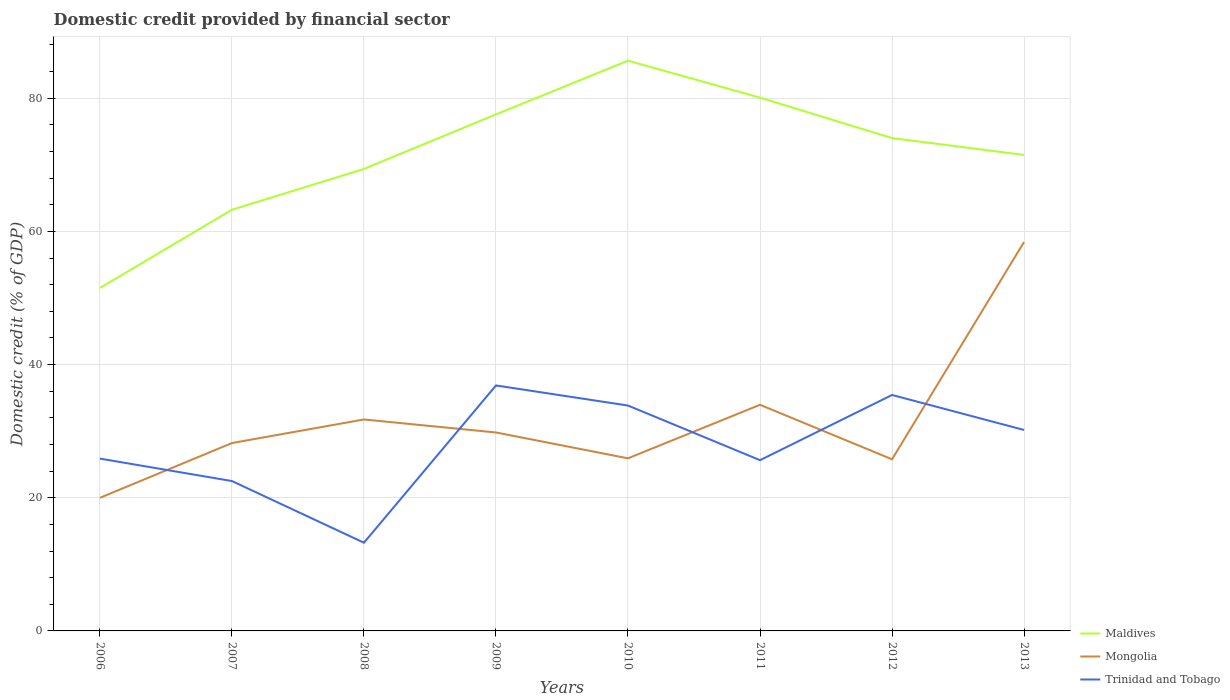Does the line corresponding to Mongolia intersect with the line corresponding to Maldives?
Your answer should be very brief. No. Is the number of lines equal to the number of legend labels?
Give a very brief answer. Yes. Across all years, what is the maximum domestic credit in Mongolia?
Keep it short and to the point. 19.99. What is the total domestic credit in Trinidad and Tobago in the graph?
Your response must be concise. -9.56. What is the difference between the highest and the second highest domestic credit in Maldives?
Your response must be concise. 34.13. Is the domestic credit in Maldives strictly greater than the domestic credit in Mongolia over the years?
Give a very brief answer. No. How many lines are there?
Give a very brief answer. 3. How many years are there in the graph?
Keep it short and to the point. 8. What is the difference between two consecutive major ticks on the Y-axis?
Offer a very short reply. 20. Are the values on the major ticks of Y-axis written in scientific E-notation?
Provide a short and direct response. No. Does the graph contain grids?
Ensure brevity in your answer.  Yes. How many legend labels are there?
Offer a very short reply. 3. How are the legend labels stacked?
Offer a terse response. Vertical. What is the title of the graph?
Your answer should be compact. Domestic credit provided by financial sector. What is the label or title of the Y-axis?
Your answer should be very brief. Domestic credit (% of GDP). What is the Domestic credit (% of GDP) of Maldives in 2006?
Provide a succinct answer. 51.5. What is the Domestic credit (% of GDP) in Mongolia in 2006?
Your response must be concise. 19.99. What is the Domestic credit (% of GDP) in Trinidad and Tobago in 2006?
Offer a very short reply. 25.88. What is the Domestic credit (% of GDP) in Maldives in 2007?
Provide a succinct answer. 63.25. What is the Domestic credit (% of GDP) in Mongolia in 2007?
Your answer should be compact. 28.21. What is the Domestic credit (% of GDP) in Trinidad and Tobago in 2007?
Offer a terse response. 22.51. What is the Domestic credit (% of GDP) of Maldives in 2008?
Your response must be concise. 69.38. What is the Domestic credit (% of GDP) of Mongolia in 2008?
Ensure brevity in your answer.  31.76. What is the Domestic credit (% of GDP) of Trinidad and Tobago in 2008?
Your answer should be compact. 13.25. What is the Domestic credit (% of GDP) in Maldives in 2009?
Provide a short and direct response. 77.58. What is the Domestic credit (% of GDP) of Mongolia in 2009?
Your answer should be very brief. 29.8. What is the Domestic credit (% of GDP) in Trinidad and Tobago in 2009?
Your response must be concise. 36.87. What is the Domestic credit (% of GDP) in Maldives in 2010?
Offer a terse response. 85.64. What is the Domestic credit (% of GDP) in Mongolia in 2010?
Your answer should be compact. 25.92. What is the Domestic credit (% of GDP) in Trinidad and Tobago in 2010?
Keep it short and to the point. 33.85. What is the Domestic credit (% of GDP) in Maldives in 2011?
Ensure brevity in your answer.  80.09. What is the Domestic credit (% of GDP) of Mongolia in 2011?
Make the answer very short. 33.96. What is the Domestic credit (% of GDP) of Trinidad and Tobago in 2011?
Offer a very short reply. 25.64. What is the Domestic credit (% of GDP) of Maldives in 2012?
Your answer should be compact. 74.02. What is the Domestic credit (% of GDP) in Mongolia in 2012?
Ensure brevity in your answer.  25.77. What is the Domestic credit (% of GDP) of Trinidad and Tobago in 2012?
Provide a succinct answer. 35.44. What is the Domestic credit (% of GDP) in Maldives in 2013?
Ensure brevity in your answer.  71.48. What is the Domestic credit (% of GDP) in Mongolia in 2013?
Provide a succinct answer. 58.41. What is the Domestic credit (% of GDP) of Trinidad and Tobago in 2013?
Offer a very short reply. 30.18. Across all years, what is the maximum Domestic credit (% of GDP) of Maldives?
Your answer should be very brief. 85.64. Across all years, what is the maximum Domestic credit (% of GDP) in Mongolia?
Provide a succinct answer. 58.41. Across all years, what is the maximum Domestic credit (% of GDP) in Trinidad and Tobago?
Keep it short and to the point. 36.87. Across all years, what is the minimum Domestic credit (% of GDP) of Maldives?
Your response must be concise. 51.5. Across all years, what is the minimum Domestic credit (% of GDP) of Mongolia?
Ensure brevity in your answer.  19.99. Across all years, what is the minimum Domestic credit (% of GDP) in Trinidad and Tobago?
Make the answer very short. 13.25. What is the total Domestic credit (% of GDP) in Maldives in the graph?
Ensure brevity in your answer.  572.94. What is the total Domestic credit (% of GDP) of Mongolia in the graph?
Offer a terse response. 253.83. What is the total Domestic credit (% of GDP) in Trinidad and Tobago in the graph?
Provide a succinct answer. 223.6. What is the difference between the Domestic credit (% of GDP) of Maldives in 2006 and that in 2007?
Ensure brevity in your answer.  -11.75. What is the difference between the Domestic credit (% of GDP) in Mongolia in 2006 and that in 2007?
Make the answer very short. -8.23. What is the difference between the Domestic credit (% of GDP) in Trinidad and Tobago in 2006 and that in 2007?
Your response must be concise. 3.37. What is the difference between the Domestic credit (% of GDP) in Maldives in 2006 and that in 2008?
Your response must be concise. -17.88. What is the difference between the Domestic credit (% of GDP) of Mongolia in 2006 and that in 2008?
Your response must be concise. -11.77. What is the difference between the Domestic credit (% of GDP) in Trinidad and Tobago in 2006 and that in 2008?
Give a very brief answer. 12.63. What is the difference between the Domestic credit (% of GDP) in Maldives in 2006 and that in 2009?
Provide a short and direct response. -26.07. What is the difference between the Domestic credit (% of GDP) of Mongolia in 2006 and that in 2009?
Your response must be concise. -9.82. What is the difference between the Domestic credit (% of GDP) of Trinidad and Tobago in 2006 and that in 2009?
Keep it short and to the point. -10.98. What is the difference between the Domestic credit (% of GDP) of Maldives in 2006 and that in 2010?
Provide a short and direct response. -34.13. What is the difference between the Domestic credit (% of GDP) of Mongolia in 2006 and that in 2010?
Give a very brief answer. -5.93. What is the difference between the Domestic credit (% of GDP) in Trinidad and Tobago in 2006 and that in 2010?
Give a very brief answer. -7.97. What is the difference between the Domestic credit (% of GDP) of Maldives in 2006 and that in 2011?
Make the answer very short. -28.58. What is the difference between the Domestic credit (% of GDP) in Mongolia in 2006 and that in 2011?
Offer a very short reply. -13.97. What is the difference between the Domestic credit (% of GDP) in Trinidad and Tobago in 2006 and that in 2011?
Offer a terse response. 0.24. What is the difference between the Domestic credit (% of GDP) of Maldives in 2006 and that in 2012?
Offer a terse response. -22.51. What is the difference between the Domestic credit (% of GDP) in Mongolia in 2006 and that in 2012?
Your response must be concise. -5.79. What is the difference between the Domestic credit (% of GDP) of Trinidad and Tobago in 2006 and that in 2012?
Offer a very short reply. -9.56. What is the difference between the Domestic credit (% of GDP) in Maldives in 2006 and that in 2013?
Your answer should be very brief. -19.98. What is the difference between the Domestic credit (% of GDP) of Mongolia in 2006 and that in 2013?
Ensure brevity in your answer.  -38.42. What is the difference between the Domestic credit (% of GDP) of Trinidad and Tobago in 2006 and that in 2013?
Offer a terse response. -4.3. What is the difference between the Domestic credit (% of GDP) in Maldives in 2007 and that in 2008?
Keep it short and to the point. -6.13. What is the difference between the Domestic credit (% of GDP) of Mongolia in 2007 and that in 2008?
Give a very brief answer. -3.54. What is the difference between the Domestic credit (% of GDP) in Trinidad and Tobago in 2007 and that in 2008?
Make the answer very short. 9.26. What is the difference between the Domestic credit (% of GDP) in Maldives in 2007 and that in 2009?
Ensure brevity in your answer.  -14.33. What is the difference between the Domestic credit (% of GDP) of Mongolia in 2007 and that in 2009?
Your answer should be very brief. -1.59. What is the difference between the Domestic credit (% of GDP) in Trinidad and Tobago in 2007 and that in 2009?
Provide a succinct answer. -14.36. What is the difference between the Domestic credit (% of GDP) of Maldives in 2007 and that in 2010?
Offer a terse response. -22.39. What is the difference between the Domestic credit (% of GDP) in Mongolia in 2007 and that in 2010?
Provide a short and direct response. 2.29. What is the difference between the Domestic credit (% of GDP) in Trinidad and Tobago in 2007 and that in 2010?
Ensure brevity in your answer.  -11.34. What is the difference between the Domestic credit (% of GDP) in Maldives in 2007 and that in 2011?
Your answer should be very brief. -16.84. What is the difference between the Domestic credit (% of GDP) in Mongolia in 2007 and that in 2011?
Offer a very short reply. -5.75. What is the difference between the Domestic credit (% of GDP) of Trinidad and Tobago in 2007 and that in 2011?
Your answer should be compact. -3.13. What is the difference between the Domestic credit (% of GDP) of Maldives in 2007 and that in 2012?
Your response must be concise. -10.77. What is the difference between the Domestic credit (% of GDP) in Mongolia in 2007 and that in 2012?
Make the answer very short. 2.44. What is the difference between the Domestic credit (% of GDP) in Trinidad and Tobago in 2007 and that in 2012?
Your answer should be compact. -12.93. What is the difference between the Domestic credit (% of GDP) in Maldives in 2007 and that in 2013?
Provide a short and direct response. -8.23. What is the difference between the Domestic credit (% of GDP) in Mongolia in 2007 and that in 2013?
Make the answer very short. -30.2. What is the difference between the Domestic credit (% of GDP) in Trinidad and Tobago in 2007 and that in 2013?
Make the answer very short. -7.67. What is the difference between the Domestic credit (% of GDP) of Maldives in 2008 and that in 2009?
Your answer should be very brief. -8.19. What is the difference between the Domestic credit (% of GDP) of Mongolia in 2008 and that in 2009?
Provide a short and direct response. 1.95. What is the difference between the Domestic credit (% of GDP) of Trinidad and Tobago in 2008 and that in 2009?
Offer a terse response. -23.62. What is the difference between the Domestic credit (% of GDP) of Maldives in 2008 and that in 2010?
Your answer should be very brief. -16.26. What is the difference between the Domestic credit (% of GDP) of Mongolia in 2008 and that in 2010?
Give a very brief answer. 5.83. What is the difference between the Domestic credit (% of GDP) in Trinidad and Tobago in 2008 and that in 2010?
Your answer should be compact. -20.6. What is the difference between the Domestic credit (% of GDP) in Maldives in 2008 and that in 2011?
Ensure brevity in your answer.  -10.71. What is the difference between the Domestic credit (% of GDP) in Mongolia in 2008 and that in 2011?
Offer a terse response. -2.2. What is the difference between the Domestic credit (% of GDP) in Trinidad and Tobago in 2008 and that in 2011?
Your response must be concise. -12.4. What is the difference between the Domestic credit (% of GDP) in Maldives in 2008 and that in 2012?
Offer a terse response. -4.63. What is the difference between the Domestic credit (% of GDP) in Mongolia in 2008 and that in 2012?
Keep it short and to the point. 5.98. What is the difference between the Domestic credit (% of GDP) in Trinidad and Tobago in 2008 and that in 2012?
Your answer should be very brief. -22.19. What is the difference between the Domestic credit (% of GDP) in Maldives in 2008 and that in 2013?
Keep it short and to the point. -2.1. What is the difference between the Domestic credit (% of GDP) of Mongolia in 2008 and that in 2013?
Ensure brevity in your answer.  -26.66. What is the difference between the Domestic credit (% of GDP) in Trinidad and Tobago in 2008 and that in 2013?
Provide a succinct answer. -16.93. What is the difference between the Domestic credit (% of GDP) of Maldives in 2009 and that in 2010?
Offer a very short reply. -8.06. What is the difference between the Domestic credit (% of GDP) in Mongolia in 2009 and that in 2010?
Offer a very short reply. 3.88. What is the difference between the Domestic credit (% of GDP) of Trinidad and Tobago in 2009 and that in 2010?
Your answer should be compact. 3.02. What is the difference between the Domestic credit (% of GDP) in Maldives in 2009 and that in 2011?
Provide a short and direct response. -2.51. What is the difference between the Domestic credit (% of GDP) in Mongolia in 2009 and that in 2011?
Offer a terse response. -4.16. What is the difference between the Domestic credit (% of GDP) in Trinidad and Tobago in 2009 and that in 2011?
Your response must be concise. 11.22. What is the difference between the Domestic credit (% of GDP) in Maldives in 2009 and that in 2012?
Give a very brief answer. 3.56. What is the difference between the Domestic credit (% of GDP) of Mongolia in 2009 and that in 2012?
Keep it short and to the point. 4.03. What is the difference between the Domestic credit (% of GDP) of Trinidad and Tobago in 2009 and that in 2012?
Your response must be concise. 1.43. What is the difference between the Domestic credit (% of GDP) of Maldives in 2009 and that in 2013?
Make the answer very short. 6.09. What is the difference between the Domestic credit (% of GDP) of Mongolia in 2009 and that in 2013?
Offer a terse response. -28.61. What is the difference between the Domestic credit (% of GDP) in Trinidad and Tobago in 2009 and that in 2013?
Your response must be concise. 6.69. What is the difference between the Domestic credit (% of GDP) in Maldives in 2010 and that in 2011?
Give a very brief answer. 5.55. What is the difference between the Domestic credit (% of GDP) of Mongolia in 2010 and that in 2011?
Give a very brief answer. -8.04. What is the difference between the Domestic credit (% of GDP) in Trinidad and Tobago in 2010 and that in 2011?
Give a very brief answer. 8.21. What is the difference between the Domestic credit (% of GDP) of Maldives in 2010 and that in 2012?
Keep it short and to the point. 11.62. What is the difference between the Domestic credit (% of GDP) in Mongolia in 2010 and that in 2012?
Your answer should be compact. 0.15. What is the difference between the Domestic credit (% of GDP) of Trinidad and Tobago in 2010 and that in 2012?
Ensure brevity in your answer.  -1.59. What is the difference between the Domestic credit (% of GDP) in Maldives in 2010 and that in 2013?
Give a very brief answer. 14.16. What is the difference between the Domestic credit (% of GDP) in Mongolia in 2010 and that in 2013?
Give a very brief answer. -32.49. What is the difference between the Domestic credit (% of GDP) in Trinidad and Tobago in 2010 and that in 2013?
Your answer should be very brief. 3.67. What is the difference between the Domestic credit (% of GDP) in Maldives in 2011 and that in 2012?
Make the answer very short. 6.07. What is the difference between the Domestic credit (% of GDP) of Mongolia in 2011 and that in 2012?
Ensure brevity in your answer.  8.19. What is the difference between the Domestic credit (% of GDP) of Trinidad and Tobago in 2011 and that in 2012?
Make the answer very short. -9.8. What is the difference between the Domestic credit (% of GDP) of Maldives in 2011 and that in 2013?
Make the answer very short. 8.61. What is the difference between the Domestic credit (% of GDP) of Mongolia in 2011 and that in 2013?
Give a very brief answer. -24.45. What is the difference between the Domestic credit (% of GDP) of Trinidad and Tobago in 2011 and that in 2013?
Your answer should be compact. -4.54. What is the difference between the Domestic credit (% of GDP) of Maldives in 2012 and that in 2013?
Your answer should be compact. 2.53. What is the difference between the Domestic credit (% of GDP) of Mongolia in 2012 and that in 2013?
Make the answer very short. -32.64. What is the difference between the Domestic credit (% of GDP) of Trinidad and Tobago in 2012 and that in 2013?
Your answer should be compact. 5.26. What is the difference between the Domestic credit (% of GDP) of Maldives in 2006 and the Domestic credit (% of GDP) of Mongolia in 2007?
Provide a short and direct response. 23.29. What is the difference between the Domestic credit (% of GDP) in Maldives in 2006 and the Domestic credit (% of GDP) in Trinidad and Tobago in 2007?
Your answer should be compact. 29. What is the difference between the Domestic credit (% of GDP) of Mongolia in 2006 and the Domestic credit (% of GDP) of Trinidad and Tobago in 2007?
Give a very brief answer. -2.52. What is the difference between the Domestic credit (% of GDP) in Maldives in 2006 and the Domestic credit (% of GDP) in Mongolia in 2008?
Provide a succinct answer. 19.75. What is the difference between the Domestic credit (% of GDP) in Maldives in 2006 and the Domestic credit (% of GDP) in Trinidad and Tobago in 2008?
Your response must be concise. 38.26. What is the difference between the Domestic credit (% of GDP) of Mongolia in 2006 and the Domestic credit (% of GDP) of Trinidad and Tobago in 2008?
Make the answer very short. 6.74. What is the difference between the Domestic credit (% of GDP) of Maldives in 2006 and the Domestic credit (% of GDP) of Mongolia in 2009?
Your response must be concise. 21.7. What is the difference between the Domestic credit (% of GDP) of Maldives in 2006 and the Domestic credit (% of GDP) of Trinidad and Tobago in 2009?
Your answer should be compact. 14.64. What is the difference between the Domestic credit (% of GDP) of Mongolia in 2006 and the Domestic credit (% of GDP) of Trinidad and Tobago in 2009?
Provide a succinct answer. -16.88. What is the difference between the Domestic credit (% of GDP) of Maldives in 2006 and the Domestic credit (% of GDP) of Mongolia in 2010?
Ensure brevity in your answer.  25.58. What is the difference between the Domestic credit (% of GDP) in Maldives in 2006 and the Domestic credit (% of GDP) in Trinidad and Tobago in 2010?
Give a very brief answer. 17.66. What is the difference between the Domestic credit (% of GDP) in Mongolia in 2006 and the Domestic credit (% of GDP) in Trinidad and Tobago in 2010?
Ensure brevity in your answer.  -13.86. What is the difference between the Domestic credit (% of GDP) in Maldives in 2006 and the Domestic credit (% of GDP) in Mongolia in 2011?
Provide a succinct answer. 17.54. What is the difference between the Domestic credit (% of GDP) of Maldives in 2006 and the Domestic credit (% of GDP) of Trinidad and Tobago in 2011?
Your answer should be very brief. 25.86. What is the difference between the Domestic credit (% of GDP) in Mongolia in 2006 and the Domestic credit (% of GDP) in Trinidad and Tobago in 2011?
Offer a terse response. -5.65. What is the difference between the Domestic credit (% of GDP) of Maldives in 2006 and the Domestic credit (% of GDP) of Mongolia in 2012?
Your response must be concise. 25.73. What is the difference between the Domestic credit (% of GDP) of Maldives in 2006 and the Domestic credit (% of GDP) of Trinidad and Tobago in 2012?
Make the answer very short. 16.07. What is the difference between the Domestic credit (% of GDP) of Mongolia in 2006 and the Domestic credit (% of GDP) of Trinidad and Tobago in 2012?
Offer a very short reply. -15.45. What is the difference between the Domestic credit (% of GDP) of Maldives in 2006 and the Domestic credit (% of GDP) of Mongolia in 2013?
Your answer should be compact. -6.91. What is the difference between the Domestic credit (% of GDP) in Maldives in 2006 and the Domestic credit (% of GDP) in Trinidad and Tobago in 2013?
Offer a terse response. 21.33. What is the difference between the Domestic credit (% of GDP) of Mongolia in 2006 and the Domestic credit (% of GDP) of Trinidad and Tobago in 2013?
Keep it short and to the point. -10.19. What is the difference between the Domestic credit (% of GDP) in Maldives in 2007 and the Domestic credit (% of GDP) in Mongolia in 2008?
Ensure brevity in your answer.  31.49. What is the difference between the Domestic credit (% of GDP) in Maldives in 2007 and the Domestic credit (% of GDP) in Trinidad and Tobago in 2008?
Offer a terse response. 50. What is the difference between the Domestic credit (% of GDP) in Mongolia in 2007 and the Domestic credit (% of GDP) in Trinidad and Tobago in 2008?
Offer a terse response. 14.97. What is the difference between the Domestic credit (% of GDP) in Maldives in 2007 and the Domestic credit (% of GDP) in Mongolia in 2009?
Your response must be concise. 33.45. What is the difference between the Domestic credit (% of GDP) of Maldives in 2007 and the Domestic credit (% of GDP) of Trinidad and Tobago in 2009?
Offer a terse response. 26.38. What is the difference between the Domestic credit (% of GDP) of Mongolia in 2007 and the Domestic credit (% of GDP) of Trinidad and Tobago in 2009?
Offer a terse response. -8.65. What is the difference between the Domestic credit (% of GDP) in Maldives in 2007 and the Domestic credit (% of GDP) in Mongolia in 2010?
Offer a very short reply. 37.33. What is the difference between the Domestic credit (% of GDP) in Maldives in 2007 and the Domestic credit (% of GDP) in Trinidad and Tobago in 2010?
Offer a terse response. 29.4. What is the difference between the Domestic credit (% of GDP) in Mongolia in 2007 and the Domestic credit (% of GDP) in Trinidad and Tobago in 2010?
Ensure brevity in your answer.  -5.63. What is the difference between the Domestic credit (% of GDP) of Maldives in 2007 and the Domestic credit (% of GDP) of Mongolia in 2011?
Offer a very short reply. 29.29. What is the difference between the Domestic credit (% of GDP) in Maldives in 2007 and the Domestic credit (% of GDP) in Trinidad and Tobago in 2011?
Make the answer very short. 37.61. What is the difference between the Domestic credit (% of GDP) in Mongolia in 2007 and the Domestic credit (% of GDP) in Trinidad and Tobago in 2011?
Make the answer very short. 2.57. What is the difference between the Domestic credit (% of GDP) in Maldives in 2007 and the Domestic credit (% of GDP) in Mongolia in 2012?
Make the answer very short. 37.48. What is the difference between the Domestic credit (% of GDP) of Maldives in 2007 and the Domestic credit (% of GDP) of Trinidad and Tobago in 2012?
Offer a very short reply. 27.81. What is the difference between the Domestic credit (% of GDP) in Mongolia in 2007 and the Domestic credit (% of GDP) in Trinidad and Tobago in 2012?
Make the answer very short. -7.22. What is the difference between the Domestic credit (% of GDP) of Maldives in 2007 and the Domestic credit (% of GDP) of Mongolia in 2013?
Your answer should be very brief. 4.84. What is the difference between the Domestic credit (% of GDP) of Maldives in 2007 and the Domestic credit (% of GDP) of Trinidad and Tobago in 2013?
Offer a very short reply. 33.07. What is the difference between the Domestic credit (% of GDP) of Mongolia in 2007 and the Domestic credit (% of GDP) of Trinidad and Tobago in 2013?
Ensure brevity in your answer.  -1.96. What is the difference between the Domestic credit (% of GDP) in Maldives in 2008 and the Domestic credit (% of GDP) in Mongolia in 2009?
Your response must be concise. 39.58. What is the difference between the Domestic credit (% of GDP) of Maldives in 2008 and the Domestic credit (% of GDP) of Trinidad and Tobago in 2009?
Provide a succinct answer. 32.52. What is the difference between the Domestic credit (% of GDP) in Mongolia in 2008 and the Domestic credit (% of GDP) in Trinidad and Tobago in 2009?
Provide a short and direct response. -5.11. What is the difference between the Domestic credit (% of GDP) in Maldives in 2008 and the Domestic credit (% of GDP) in Mongolia in 2010?
Your response must be concise. 43.46. What is the difference between the Domestic credit (% of GDP) in Maldives in 2008 and the Domestic credit (% of GDP) in Trinidad and Tobago in 2010?
Ensure brevity in your answer.  35.54. What is the difference between the Domestic credit (% of GDP) of Mongolia in 2008 and the Domestic credit (% of GDP) of Trinidad and Tobago in 2010?
Ensure brevity in your answer.  -2.09. What is the difference between the Domestic credit (% of GDP) in Maldives in 2008 and the Domestic credit (% of GDP) in Mongolia in 2011?
Offer a very short reply. 35.42. What is the difference between the Domestic credit (% of GDP) in Maldives in 2008 and the Domestic credit (% of GDP) in Trinidad and Tobago in 2011?
Offer a terse response. 43.74. What is the difference between the Domestic credit (% of GDP) of Mongolia in 2008 and the Domestic credit (% of GDP) of Trinidad and Tobago in 2011?
Your answer should be compact. 6.11. What is the difference between the Domestic credit (% of GDP) of Maldives in 2008 and the Domestic credit (% of GDP) of Mongolia in 2012?
Offer a very short reply. 43.61. What is the difference between the Domestic credit (% of GDP) of Maldives in 2008 and the Domestic credit (% of GDP) of Trinidad and Tobago in 2012?
Give a very brief answer. 33.95. What is the difference between the Domestic credit (% of GDP) in Mongolia in 2008 and the Domestic credit (% of GDP) in Trinidad and Tobago in 2012?
Offer a very short reply. -3.68. What is the difference between the Domestic credit (% of GDP) of Maldives in 2008 and the Domestic credit (% of GDP) of Mongolia in 2013?
Your response must be concise. 10.97. What is the difference between the Domestic credit (% of GDP) of Maldives in 2008 and the Domestic credit (% of GDP) of Trinidad and Tobago in 2013?
Offer a terse response. 39.21. What is the difference between the Domestic credit (% of GDP) in Mongolia in 2008 and the Domestic credit (% of GDP) in Trinidad and Tobago in 2013?
Keep it short and to the point. 1.58. What is the difference between the Domestic credit (% of GDP) in Maldives in 2009 and the Domestic credit (% of GDP) in Mongolia in 2010?
Your answer should be compact. 51.66. What is the difference between the Domestic credit (% of GDP) in Maldives in 2009 and the Domestic credit (% of GDP) in Trinidad and Tobago in 2010?
Provide a succinct answer. 43.73. What is the difference between the Domestic credit (% of GDP) of Mongolia in 2009 and the Domestic credit (% of GDP) of Trinidad and Tobago in 2010?
Provide a succinct answer. -4.04. What is the difference between the Domestic credit (% of GDP) of Maldives in 2009 and the Domestic credit (% of GDP) of Mongolia in 2011?
Your answer should be compact. 43.62. What is the difference between the Domestic credit (% of GDP) in Maldives in 2009 and the Domestic credit (% of GDP) in Trinidad and Tobago in 2011?
Provide a short and direct response. 51.93. What is the difference between the Domestic credit (% of GDP) of Mongolia in 2009 and the Domestic credit (% of GDP) of Trinidad and Tobago in 2011?
Your response must be concise. 4.16. What is the difference between the Domestic credit (% of GDP) of Maldives in 2009 and the Domestic credit (% of GDP) of Mongolia in 2012?
Your answer should be very brief. 51.8. What is the difference between the Domestic credit (% of GDP) in Maldives in 2009 and the Domestic credit (% of GDP) in Trinidad and Tobago in 2012?
Give a very brief answer. 42.14. What is the difference between the Domestic credit (% of GDP) of Mongolia in 2009 and the Domestic credit (% of GDP) of Trinidad and Tobago in 2012?
Make the answer very short. -5.63. What is the difference between the Domestic credit (% of GDP) of Maldives in 2009 and the Domestic credit (% of GDP) of Mongolia in 2013?
Make the answer very short. 19.16. What is the difference between the Domestic credit (% of GDP) of Maldives in 2009 and the Domestic credit (% of GDP) of Trinidad and Tobago in 2013?
Provide a short and direct response. 47.4. What is the difference between the Domestic credit (% of GDP) of Mongolia in 2009 and the Domestic credit (% of GDP) of Trinidad and Tobago in 2013?
Your answer should be compact. -0.37. What is the difference between the Domestic credit (% of GDP) in Maldives in 2010 and the Domestic credit (% of GDP) in Mongolia in 2011?
Your response must be concise. 51.68. What is the difference between the Domestic credit (% of GDP) of Maldives in 2010 and the Domestic credit (% of GDP) of Trinidad and Tobago in 2011?
Keep it short and to the point. 60. What is the difference between the Domestic credit (% of GDP) of Mongolia in 2010 and the Domestic credit (% of GDP) of Trinidad and Tobago in 2011?
Make the answer very short. 0.28. What is the difference between the Domestic credit (% of GDP) in Maldives in 2010 and the Domestic credit (% of GDP) in Mongolia in 2012?
Your answer should be very brief. 59.86. What is the difference between the Domestic credit (% of GDP) of Maldives in 2010 and the Domestic credit (% of GDP) of Trinidad and Tobago in 2012?
Give a very brief answer. 50.2. What is the difference between the Domestic credit (% of GDP) of Mongolia in 2010 and the Domestic credit (% of GDP) of Trinidad and Tobago in 2012?
Provide a short and direct response. -9.52. What is the difference between the Domestic credit (% of GDP) of Maldives in 2010 and the Domestic credit (% of GDP) of Mongolia in 2013?
Offer a very short reply. 27.23. What is the difference between the Domestic credit (% of GDP) of Maldives in 2010 and the Domestic credit (% of GDP) of Trinidad and Tobago in 2013?
Provide a succinct answer. 55.46. What is the difference between the Domestic credit (% of GDP) of Mongolia in 2010 and the Domestic credit (% of GDP) of Trinidad and Tobago in 2013?
Your answer should be very brief. -4.26. What is the difference between the Domestic credit (% of GDP) of Maldives in 2011 and the Domestic credit (% of GDP) of Mongolia in 2012?
Offer a very short reply. 54.31. What is the difference between the Domestic credit (% of GDP) of Maldives in 2011 and the Domestic credit (% of GDP) of Trinidad and Tobago in 2012?
Provide a short and direct response. 44.65. What is the difference between the Domestic credit (% of GDP) in Mongolia in 2011 and the Domestic credit (% of GDP) in Trinidad and Tobago in 2012?
Give a very brief answer. -1.48. What is the difference between the Domestic credit (% of GDP) in Maldives in 2011 and the Domestic credit (% of GDP) in Mongolia in 2013?
Offer a very short reply. 21.68. What is the difference between the Domestic credit (% of GDP) in Maldives in 2011 and the Domestic credit (% of GDP) in Trinidad and Tobago in 2013?
Your answer should be compact. 49.91. What is the difference between the Domestic credit (% of GDP) in Mongolia in 2011 and the Domestic credit (% of GDP) in Trinidad and Tobago in 2013?
Make the answer very short. 3.78. What is the difference between the Domestic credit (% of GDP) of Maldives in 2012 and the Domestic credit (% of GDP) of Mongolia in 2013?
Offer a terse response. 15.6. What is the difference between the Domestic credit (% of GDP) in Maldives in 2012 and the Domestic credit (% of GDP) in Trinidad and Tobago in 2013?
Offer a very short reply. 43.84. What is the difference between the Domestic credit (% of GDP) in Mongolia in 2012 and the Domestic credit (% of GDP) in Trinidad and Tobago in 2013?
Your answer should be compact. -4.4. What is the average Domestic credit (% of GDP) of Maldives per year?
Give a very brief answer. 71.62. What is the average Domestic credit (% of GDP) of Mongolia per year?
Give a very brief answer. 31.73. What is the average Domestic credit (% of GDP) of Trinidad and Tobago per year?
Your answer should be very brief. 27.95. In the year 2006, what is the difference between the Domestic credit (% of GDP) of Maldives and Domestic credit (% of GDP) of Mongolia?
Provide a short and direct response. 31.52. In the year 2006, what is the difference between the Domestic credit (% of GDP) of Maldives and Domestic credit (% of GDP) of Trinidad and Tobago?
Make the answer very short. 25.62. In the year 2006, what is the difference between the Domestic credit (% of GDP) in Mongolia and Domestic credit (% of GDP) in Trinidad and Tobago?
Your answer should be compact. -5.89. In the year 2007, what is the difference between the Domestic credit (% of GDP) in Maldives and Domestic credit (% of GDP) in Mongolia?
Provide a short and direct response. 35.04. In the year 2007, what is the difference between the Domestic credit (% of GDP) in Maldives and Domestic credit (% of GDP) in Trinidad and Tobago?
Provide a succinct answer. 40.74. In the year 2007, what is the difference between the Domestic credit (% of GDP) in Mongolia and Domestic credit (% of GDP) in Trinidad and Tobago?
Offer a terse response. 5.71. In the year 2008, what is the difference between the Domestic credit (% of GDP) in Maldives and Domestic credit (% of GDP) in Mongolia?
Ensure brevity in your answer.  37.63. In the year 2008, what is the difference between the Domestic credit (% of GDP) in Maldives and Domestic credit (% of GDP) in Trinidad and Tobago?
Offer a very short reply. 56.14. In the year 2008, what is the difference between the Domestic credit (% of GDP) of Mongolia and Domestic credit (% of GDP) of Trinidad and Tobago?
Your answer should be very brief. 18.51. In the year 2009, what is the difference between the Domestic credit (% of GDP) of Maldives and Domestic credit (% of GDP) of Mongolia?
Keep it short and to the point. 47.77. In the year 2009, what is the difference between the Domestic credit (% of GDP) in Maldives and Domestic credit (% of GDP) in Trinidad and Tobago?
Make the answer very short. 40.71. In the year 2009, what is the difference between the Domestic credit (% of GDP) in Mongolia and Domestic credit (% of GDP) in Trinidad and Tobago?
Provide a short and direct response. -7.06. In the year 2010, what is the difference between the Domestic credit (% of GDP) in Maldives and Domestic credit (% of GDP) in Mongolia?
Provide a short and direct response. 59.72. In the year 2010, what is the difference between the Domestic credit (% of GDP) in Maldives and Domestic credit (% of GDP) in Trinidad and Tobago?
Provide a short and direct response. 51.79. In the year 2010, what is the difference between the Domestic credit (% of GDP) of Mongolia and Domestic credit (% of GDP) of Trinidad and Tobago?
Offer a terse response. -7.93. In the year 2011, what is the difference between the Domestic credit (% of GDP) of Maldives and Domestic credit (% of GDP) of Mongolia?
Ensure brevity in your answer.  46.13. In the year 2011, what is the difference between the Domestic credit (% of GDP) in Maldives and Domestic credit (% of GDP) in Trinidad and Tobago?
Provide a succinct answer. 54.45. In the year 2011, what is the difference between the Domestic credit (% of GDP) in Mongolia and Domestic credit (% of GDP) in Trinidad and Tobago?
Provide a short and direct response. 8.32. In the year 2012, what is the difference between the Domestic credit (% of GDP) of Maldives and Domestic credit (% of GDP) of Mongolia?
Make the answer very short. 48.24. In the year 2012, what is the difference between the Domestic credit (% of GDP) of Maldives and Domestic credit (% of GDP) of Trinidad and Tobago?
Ensure brevity in your answer.  38.58. In the year 2012, what is the difference between the Domestic credit (% of GDP) in Mongolia and Domestic credit (% of GDP) in Trinidad and Tobago?
Your answer should be very brief. -9.66. In the year 2013, what is the difference between the Domestic credit (% of GDP) in Maldives and Domestic credit (% of GDP) in Mongolia?
Your response must be concise. 13.07. In the year 2013, what is the difference between the Domestic credit (% of GDP) of Maldives and Domestic credit (% of GDP) of Trinidad and Tobago?
Offer a very short reply. 41.3. In the year 2013, what is the difference between the Domestic credit (% of GDP) of Mongolia and Domestic credit (% of GDP) of Trinidad and Tobago?
Offer a terse response. 28.24. What is the ratio of the Domestic credit (% of GDP) in Maldives in 2006 to that in 2007?
Your response must be concise. 0.81. What is the ratio of the Domestic credit (% of GDP) in Mongolia in 2006 to that in 2007?
Your answer should be very brief. 0.71. What is the ratio of the Domestic credit (% of GDP) in Trinidad and Tobago in 2006 to that in 2007?
Make the answer very short. 1.15. What is the ratio of the Domestic credit (% of GDP) in Maldives in 2006 to that in 2008?
Your response must be concise. 0.74. What is the ratio of the Domestic credit (% of GDP) of Mongolia in 2006 to that in 2008?
Keep it short and to the point. 0.63. What is the ratio of the Domestic credit (% of GDP) in Trinidad and Tobago in 2006 to that in 2008?
Offer a terse response. 1.95. What is the ratio of the Domestic credit (% of GDP) of Maldives in 2006 to that in 2009?
Make the answer very short. 0.66. What is the ratio of the Domestic credit (% of GDP) of Mongolia in 2006 to that in 2009?
Your answer should be compact. 0.67. What is the ratio of the Domestic credit (% of GDP) in Trinidad and Tobago in 2006 to that in 2009?
Provide a succinct answer. 0.7. What is the ratio of the Domestic credit (% of GDP) of Maldives in 2006 to that in 2010?
Provide a short and direct response. 0.6. What is the ratio of the Domestic credit (% of GDP) in Mongolia in 2006 to that in 2010?
Your response must be concise. 0.77. What is the ratio of the Domestic credit (% of GDP) of Trinidad and Tobago in 2006 to that in 2010?
Ensure brevity in your answer.  0.76. What is the ratio of the Domestic credit (% of GDP) of Maldives in 2006 to that in 2011?
Provide a succinct answer. 0.64. What is the ratio of the Domestic credit (% of GDP) of Mongolia in 2006 to that in 2011?
Provide a succinct answer. 0.59. What is the ratio of the Domestic credit (% of GDP) of Trinidad and Tobago in 2006 to that in 2011?
Offer a very short reply. 1.01. What is the ratio of the Domestic credit (% of GDP) in Maldives in 2006 to that in 2012?
Your answer should be very brief. 0.7. What is the ratio of the Domestic credit (% of GDP) of Mongolia in 2006 to that in 2012?
Ensure brevity in your answer.  0.78. What is the ratio of the Domestic credit (% of GDP) in Trinidad and Tobago in 2006 to that in 2012?
Provide a succinct answer. 0.73. What is the ratio of the Domestic credit (% of GDP) in Maldives in 2006 to that in 2013?
Provide a succinct answer. 0.72. What is the ratio of the Domestic credit (% of GDP) in Mongolia in 2006 to that in 2013?
Give a very brief answer. 0.34. What is the ratio of the Domestic credit (% of GDP) of Trinidad and Tobago in 2006 to that in 2013?
Your answer should be very brief. 0.86. What is the ratio of the Domestic credit (% of GDP) in Maldives in 2007 to that in 2008?
Provide a succinct answer. 0.91. What is the ratio of the Domestic credit (% of GDP) of Mongolia in 2007 to that in 2008?
Offer a terse response. 0.89. What is the ratio of the Domestic credit (% of GDP) of Trinidad and Tobago in 2007 to that in 2008?
Give a very brief answer. 1.7. What is the ratio of the Domestic credit (% of GDP) of Maldives in 2007 to that in 2009?
Keep it short and to the point. 0.82. What is the ratio of the Domestic credit (% of GDP) of Mongolia in 2007 to that in 2009?
Your answer should be very brief. 0.95. What is the ratio of the Domestic credit (% of GDP) in Trinidad and Tobago in 2007 to that in 2009?
Your answer should be very brief. 0.61. What is the ratio of the Domestic credit (% of GDP) of Maldives in 2007 to that in 2010?
Provide a short and direct response. 0.74. What is the ratio of the Domestic credit (% of GDP) in Mongolia in 2007 to that in 2010?
Provide a short and direct response. 1.09. What is the ratio of the Domestic credit (% of GDP) in Trinidad and Tobago in 2007 to that in 2010?
Keep it short and to the point. 0.67. What is the ratio of the Domestic credit (% of GDP) in Maldives in 2007 to that in 2011?
Offer a very short reply. 0.79. What is the ratio of the Domestic credit (% of GDP) of Mongolia in 2007 to that in 2011?
Ensure brevity in your answer.  0.83. What is the ratio of the Domestic credit (% of GDP) of Trinidad and Tobago in 2007 to that in 2011?
Provide a short and direct response. 0.88. What is the ratio of the Domestic credit (% of GDP) of Maldives in 2007 to that in 2012?
Your answer should be very brief. 0.85. What is the ratio of the Domestic credit (% of GDP) of Mongolia in 2007 to that in 2012?
Keep it short and to the point. 1.09. What is the ratio of the Domestic credit (% of GDP) in Trinidad and Tobago in 2007 to that in 2012?
Your answer should be compact. 0.64. What is the ratio of the Domestic credit (% of GDP) of Maldives in 2007 to that in 2013?
Keep it short and to the point. 0.88. What is the ratio of the Domestic credit (% of GDP) of Mongolia in 2007 to that in 2013?
Provide a short and direct response. 0.48. What is the ratio of the Domestic credit (% of GDP) of Trinidad and Tobago in 2007 to that in 2013?
Provide a short and direct response. 0.75. What is the ratio of the Domestic credit (% of GDP) of Maldives in 2008 to that in 2009?
Provide a succinct answer. 0.89. What is the ratio of the Domestic credit (% of GDP) of Mongolia in 2008 to that in 2009?
Provide a succinct answer. 1.07. What is the ratio of the Domestic credit (% of GDP) in Trinidad and Tobago in 2008 to that in 2009?
Your answer should be compact. 0.36. What is the ratio of the Domestic credit (% of GDP) of Maldives in 2008 to that in 2010?
Ensure brevity in your answer.  0.81. What is the ratio of the Domestic credit (% of GDP) of Mongolia in 2008 to that in 2010?
Ensure brevity in your answer.  1.23. What is the ratio of the Domestic credit (% of GDP) of Trinidad and Tobago in 2008 to that in 2010?
Your response must be concise. 0.39. What is the ratio of the Domestic credit (% of GDP) in Maldives in 2008 to that in 2011?
Provide a short and direct response. 0.87. What is the ratio of the Domestic credit (% of GDP) of Mongolia in 2008 to that in 2011?
Offer a very short reply. 0.94. What is the ratio of the Domestic credit (% of GDP) in Trinidad and Tobago in 2008 to that in 2011?
Your answer should be compact. 0.52. What is the ratio of the Domestic credit (% of GDP) in Maldives in 2008 to that in 2012?
Offer a very short reply. 0.94. What is the ratio of the Domestic credit (% of GDP) of Mongolia in 2008 to that in 2012?
Make the answer very short. 1.23. What is the ratio of the Domestic credit (% of GDP) of Trinidad and Tobago in 2008 to that in 2012?
Your response must be concise. 0.37. What is the ratio of the Domestic credit (% of GDP) in Maldives in 2008 to that in 2013?
Keep it short and to the point. 0.97. What is the ratio of the Domestic credit (% of GDP) of Mongolia in 2008 to that in 2013?
Offer a terse response. 0.54. What is the ratio of the Domestic credit (% of GDP) in Trinidad and Tobago in 2008 to that in 2013?
Your answer should be compact. 0.44. What is the ratio of the Domestic credit (% of GDP) of Maldives in 2009 to that in 2010?
Your answer should be very brief. 0.91. What is the ratio of the Domestic credit (% of GDP) in Mongolia in 2009 to that in 2010?
Give a very brief answer. 1.15. What is the ratio of the Domestic credit (% of GDP) in Trinidad and Tobago in 2009 to that in 2010?
Your response must be concise. 1.09. What is the ratio of the Domestic credit (% of GDP) of Maldives in 2009 to that in 2011?
Provide a succinct answer. 0.97. What is the ratio of the Domestic credit (% of GDP) of Mongolia in 2009 to that in 2011?
Ensure brevity in your answer.  0.88. What is the ratio of the Domestic credit (% of GDP) in Trinidad and Tobago in 2009 to that in 2011?
Your answer should be very brief. 1.44. What is the ratio of the Domestic credit (% of GDP) in Maldives in 2009 to that in 2012?
Provide a short and direct response. 1.05. What is the ratio of the Domestic credit (% of GDP) in Mongolia in 2009 to that in 2012?
Provide a short and direct response. 1.16. What is the ratio of the Domestic credit (% of GDP) in Trinidad and Tobago in 2009 to that in 2012?
Provide a short and direct response. 1.04. What is the ratio of the Domestic credit (% of GDP) in Maldives in 2009 to that in 2013?
Provide a succinct answer. 1.09. What is the ratio of the Domestic credit (% of GDP) of Mongolia in 2009 to that in 2013?
Your answer should be very brief. 0.51. What is the ratio of the Domestic credit (% of GDP) of Trinidad and Tobago in 2009 to that in 2013?
Offer a very short reply. 1.22. What is the ratio of the Domestic credit (% of GDP) of Maldives in 2010 to that in 2011?
Your answer should be very brief. 1.07. What is the ratio of the Domestic credit (% of GDP) in Mongolia in 2010 to that in 2011?
Offer a very short reply. 0.76. What is the ratio of the Domestic credit (% of GDP) in Trinidad and Tobago in 2010 to that in 2011?
Provide a short and direct response. 1.32. What is the ratio of the Domestic credit (% of GDP) of Maldives in 2010 to that in 2012?
Offer a terse response. 1.16. What is the ratio of the Domestic credit (% of GDP) in Trinidad and Tobago in 2010 to that in 2012?
Give a very brief answer. 0.96. What is the ratio of the Domestic credit (% of GDP) in Maldives in 2010 to that in 2013?
Provide a succinct answer. 1.2. What is the ratio of the Domestic credit (% of GDP) of Mongolia in 2010 to that in 2013?
Give a very brief answer. 0.44. What is the ratio of the Domestic credit (% of GDP) of Trinidad and Tobago in 2010 to that in 2013?
Your response must be concise. 1.12. What is the ratio of the Domestic credit (% of GDP) in Maldives in 2011 to that in 2012?
Ensure brevity in your answer.  1.08. What is the ratio of the Domestic credit (% of GDP) of Mongolia in 2011 to that in 2012?
Provide a short and direct response. 1.32. What is the ratio of the Domestic credit (% of GDP) in Trinidad and Tobago in 2011 to that in 2012?
Keep it short and to the point. 0.72. What is the ratio of the Domestic credit (% of GDP) in Maldives in 2011 to that in 2013?
Your answer should be compact. 1.12. What is the ratio of the Domestic credit (% of GDP) in Mongolia in 2011 to that in 2013?
Offer a terse response. 0.58. What is the ratio of the Domestic credit (% of GDP) in Trinidad and Tobago in 2011 to that in 2013?
Your response must be concise. 0.85. What is the ratio of the Domestic credit (% of GDP) in Maldives in 2012 to that in 2013?
Your answer should be very brief. 1.04. What is the ratio of the Domestic credit (% of GDP) of Mongolia in 2012 to that in 2013?
Give a very brief answer. 0.44. What is the ratio of the Domestic credit (% of GDP) of Trinidad and Tobago in 2012 to that in 2013?
Give a very brief answer. 1.17. What is the difference between the highest and the second highest Domestic credit (% of GDP) of Maldives?
Provide a short and direct response. 5.55. What is the difference between the highest and the second highest Domestic credit (% of GDP) of Mongolia?
Ensure brevity in your answer.  24.45. What is the difference between the highest and the second highest Domestic credit (% of GDP) of Trinidad and Tobago?
Provide a short and direct response. 1.43. What is the difference between the highest and the lowest Domestic credit (% of GDP) of Maldives?
Provide a succinct answer. 34.13. What is the difference between the highest and the lowest Domestic credit (% of GDP) in Mongolia?
Give a very brief answer. 38.42. What is the difference between the highest and the lowest Domestic credit (% of GDP) of Trinidad and Tobago?
Keep it short and to the point. 23.62. 